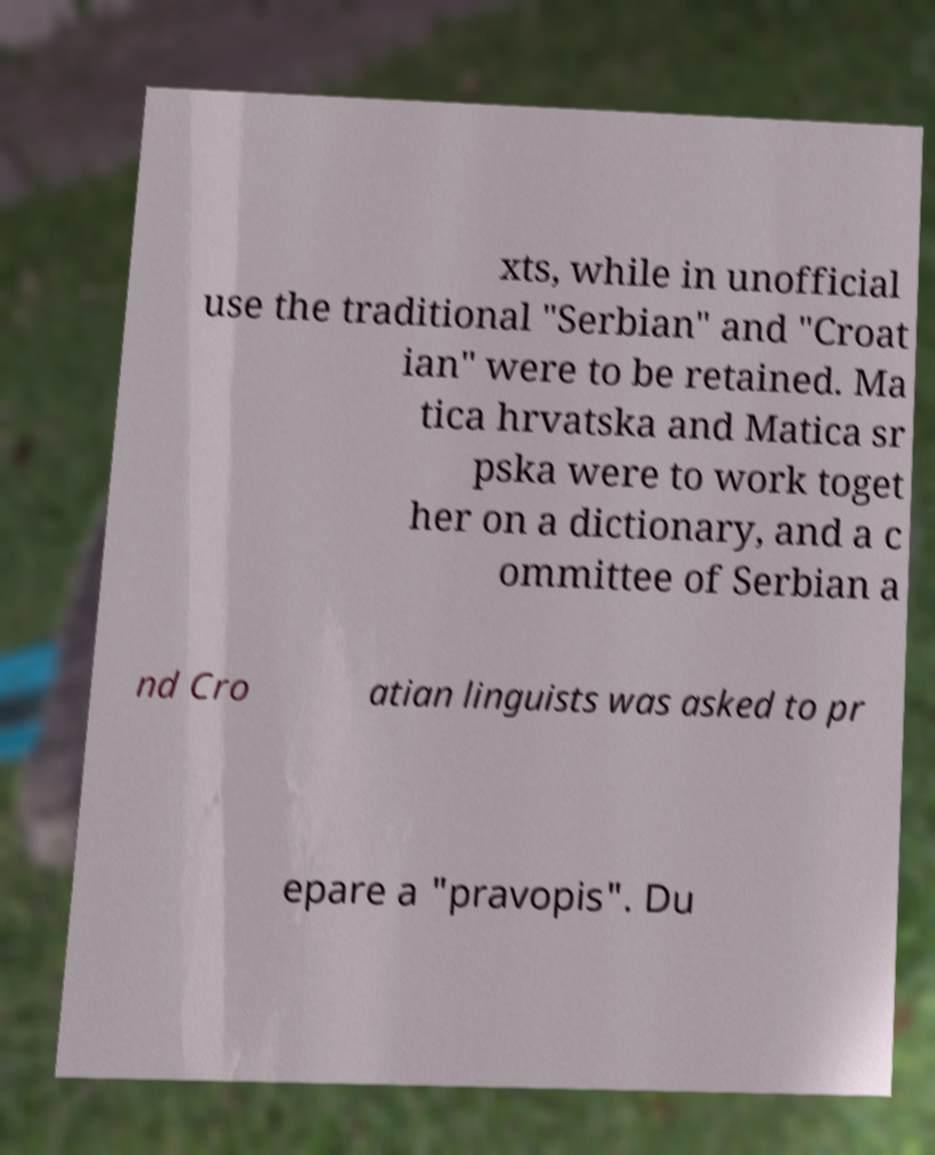What messages or text are displayed in this image? I need them in a readable, typed format. xts, while in unofficial use the traditional "Serbian" and "Croat ian" were to be retained. Ma tica hrvatska and Matica sr pska were to work toget her on a dictionary, and a c ommittee of Serbian a nd Cro atian linguists was asked to pr epare a "pravopis". Du 